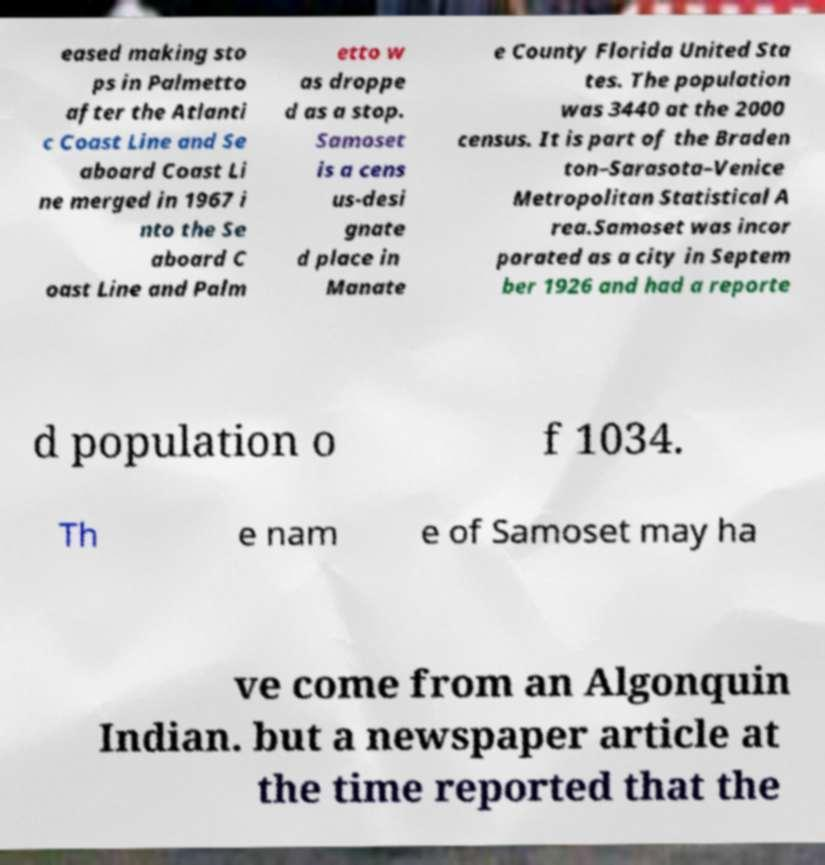There's text embedded in this image that I need extracted. Can you transcribe it verbatim? eased making sto ps in Palmetto after the Atlanti c Coast Line and Se aboard Coast Li ne merged in 1967 i nto the Se aboard C oast Line and Palm etto w as droppe d as a stop. Samoset is a cens us-desi gnate d place in Manate e County Florida United Sta tes. The population was 3440 at the 2000 census. It is part of the Braden ton–Sarasota–Venice Metropolitan Statistical A rea.Samoset was incor porated as a city in Septem ber 1926 and had a reporte d population o f 1034. Th e nam e of Samoset may ha ve come from an Algonquin Indian. but a newspaper article at the time reported that the 